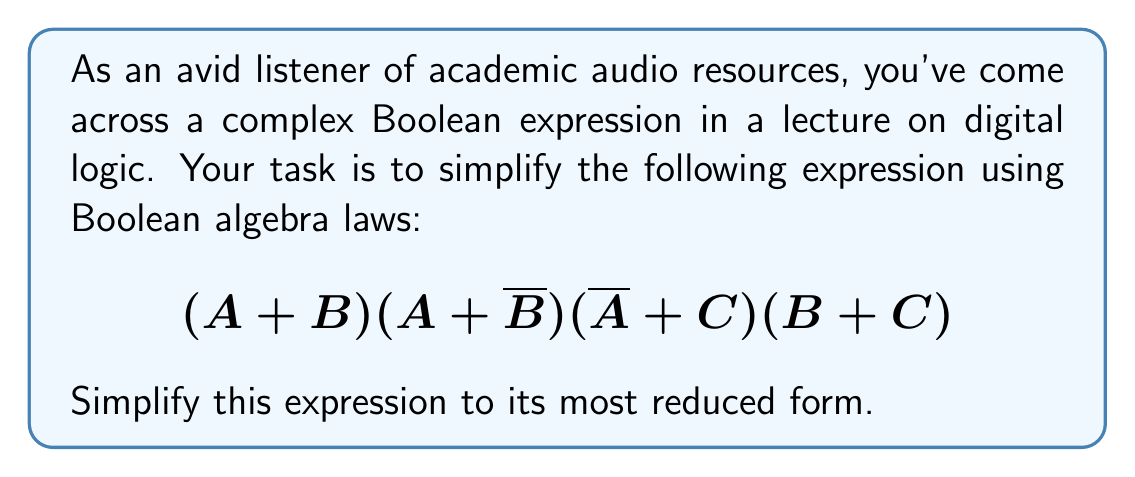Help me with this question. Let's simplify this expression step by step using Boolean algebra laws:

1) First, let's apply the distributive law to the first two terms:
   $$(A + B)(A + \overline{B}) = A + B\overline{B}$$
   
   Note that $B\overline{B} = 0$ (complement law), so this simplifies to just $A$.

2) Our expression is now:
   $$A(\overline{A} + C)(B + C)$$

3) Let's distribute $A$ over $(\overline{A} + C)$:
   $$A\overline{A} + AC)(B + C)$$
   
   $A\overline{A} = 0$ (complement law), so this simplifies to:
   $$(AC)(B + C)$$

4) Now, let's distribute $AC$ over $(B + C)$:
   $$ACB + ACC$$

5) $ACC$ can be simplified to $AC$ because $C \cdot C = C$ (idempotent law).

6) Our final simplified expression is:
   $$ACB + AC$$

7) We can factor out $AC$:
   $$AC(B + 1)$$

8) Since $B + 1 = 1$ (identity law), our final simplification is:
   $$AC$$
Answer: $AC$ 